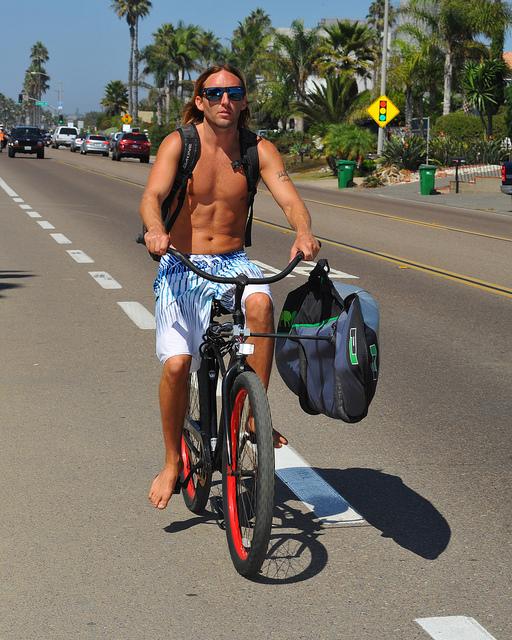Is the person wearing wig?
Give a very brief answer. No. Is the man riding on a dirt path?
Concise answer only. No. How can you tell the weather is very warm?
Keep it brief. Yes. What type of footwear is the man wearing?
Give a very brief answer. None. What is the man carrying on his bike?
Give a very brief answer. Backpack. What object could help the couple carry lunch on their bikes?
Write a very short answer. Bag. How many bike shadows are there?
Keep it brief. 1. Is he riding with no hands?
Give a very brief answer. No. What is on the person's feet?
Quick response, please. Nothing. Is the man driving a car?
Be succinct. No. Are there any sport bikes in this picture?
Answer briefly. Yes. What color bike is the man riding?
Answer briefly. Black. Does this bicycle have a basket?
Short answer required. No. Where is the man riding his bike?
Concise answer only. Road. What is this person riding?
Short answer required. Bike. 